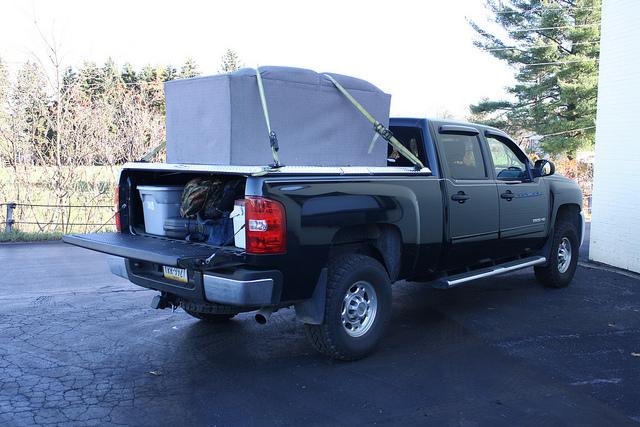Do they need tire chains?
Quick response, please. No. What is on the back of the truck?
Be succinct. Sofa. What type of truck is this?
Be succinct. Pick up. What picture is on the back of the truck?
Answer briefly. None. What color is the truck?
Write a very short answer. Black. Why is the couch on top of the truck?
Keep it brief. Moving. 